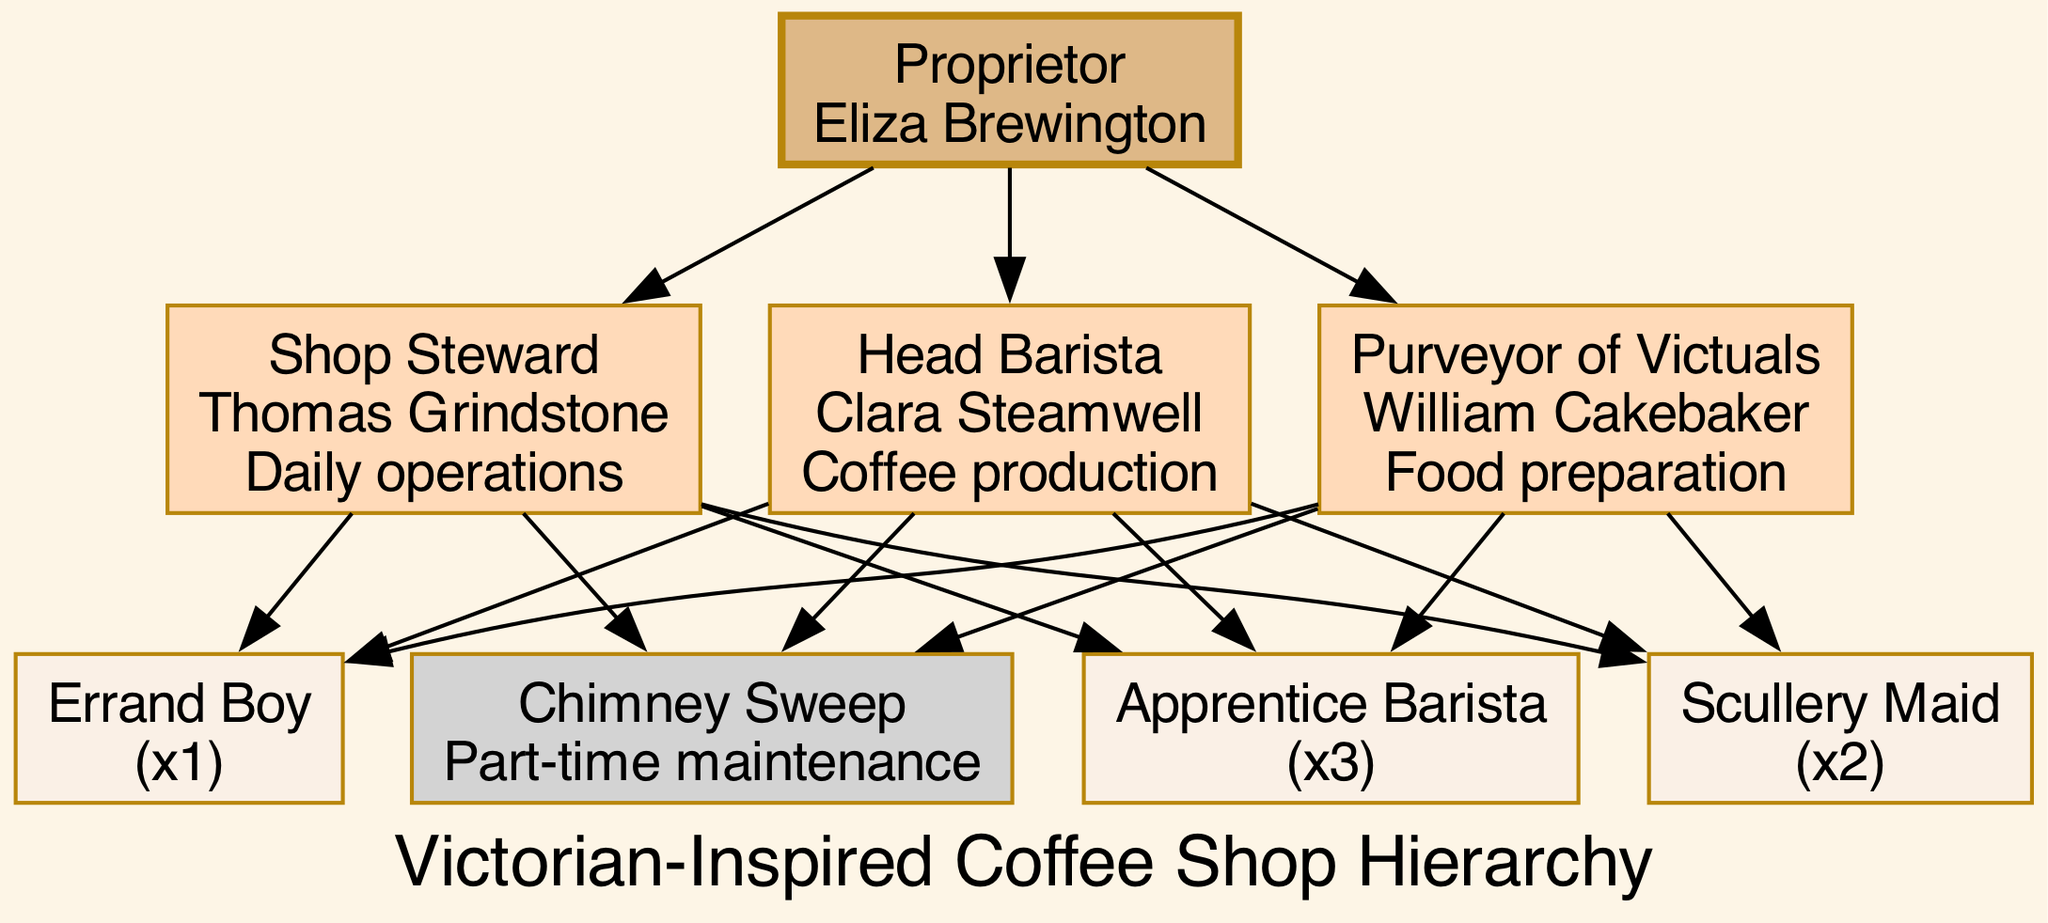What is the title of the top-level position in the hierarchy? The top-level position is labeled as "Proprietor," and the name associated with it is "Eliza Brewington."
Answer: Proprietor How many second-level staff members are there? There are three second-level staff members: Shop Steward, Head Barista, and Purveyor of Victuals.
Answer: 3 What are the responsibilities of the Head Barista? The responsibilities of the Head Barista, Clara Steamwell, are specifically listed as "Coffee production."
Answer: Coffee production How many Apprentice Baristas are there? In the diagram, there are three Apprentice Baristas, which is indicated by the count next to the title.
Answer: 3 Which position has the least number of staff? The position of Errand Boy has the least number of staff at just one person, as noted in the third-level staff category.
Answer: Errand Boy Which node connects the Proprietor to the Chimney Sweep? The Proprietor connects to the Chimney Sweep through the second-level positions, indicating that each of the second-level staff members has a connection to the Chimney Sweep.
Answer: All second-level positions What is the role immediately below the Proprietor in the hierarchy? The role immediately below the Proprietor (Eliza Brewington) is the Shop Steward (Thomas Grindstone), who oversees daily operations.
Answer: Shop Steward How many total positions are in the third level? The third level includes three different roles: Apprentice Barista, Scullery Maid, and Errand Boy. Therefore, when added together, there are a total of six positions (3 + 2 + 1).
Answer: 6 What color represents the second-level staff in the diagram? The second-level staff positions are represented with the color "peachpuff."
Answer: peachpuff 